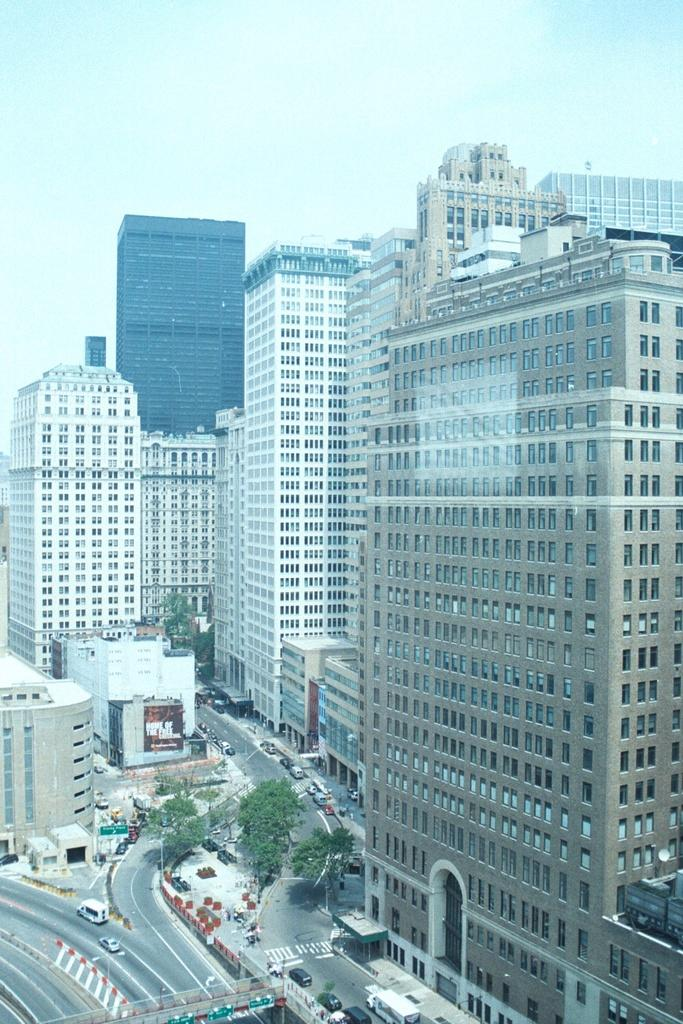What is located in the center of the image? There are buildings in the center of the image. What can be seen running through the image? There is a road in the image. What type of vehicles are present at the bottom of the image? There are cars at the bottom of the image. What type of natural elements can be seen in the image? There are trees in the image. Can you see any letters being played on a guitar in the image? There are no letters or guitars present in the image. How many people are jumping in the image? There is no jumping or people visible in the image. 